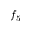Convert formula to latex. <formula><loc_0><loc_0><loc_500><loc_500>f _ { 5 }</formula> 